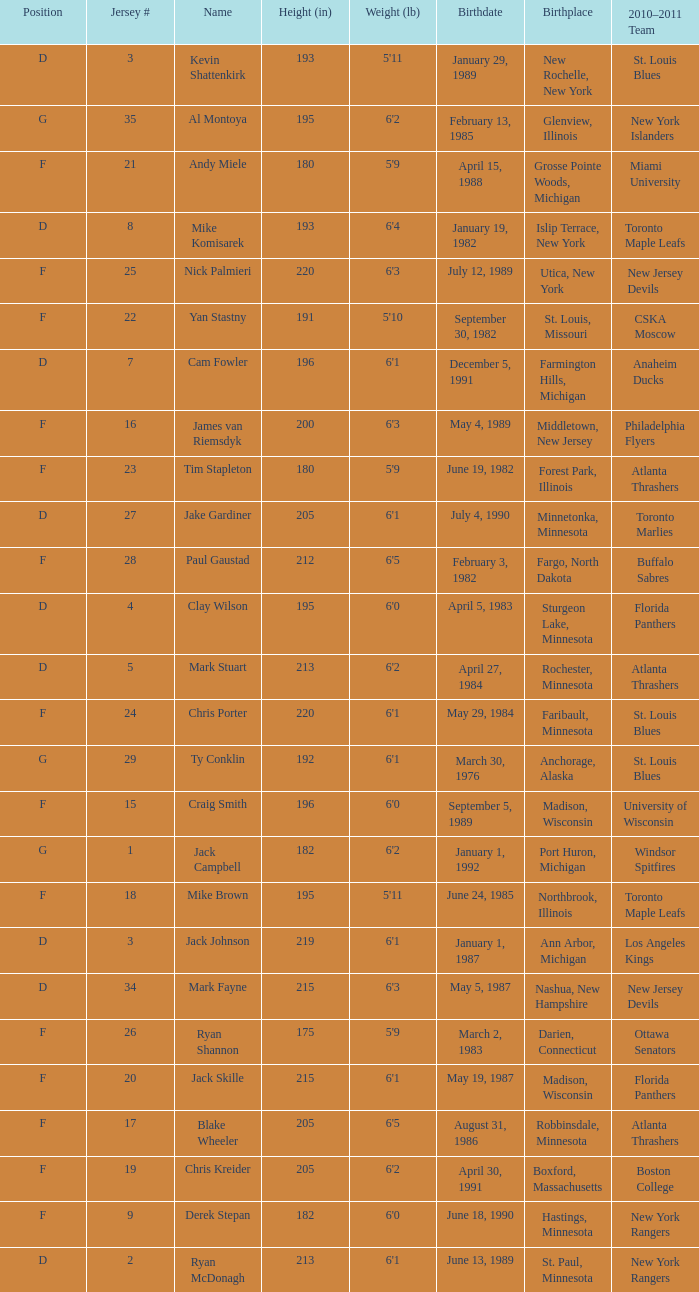Which birthplace's height in inches was more than 192 when the position was d and the birthday was April 5, 1983? Sturgeon Lake, Minnesota. 